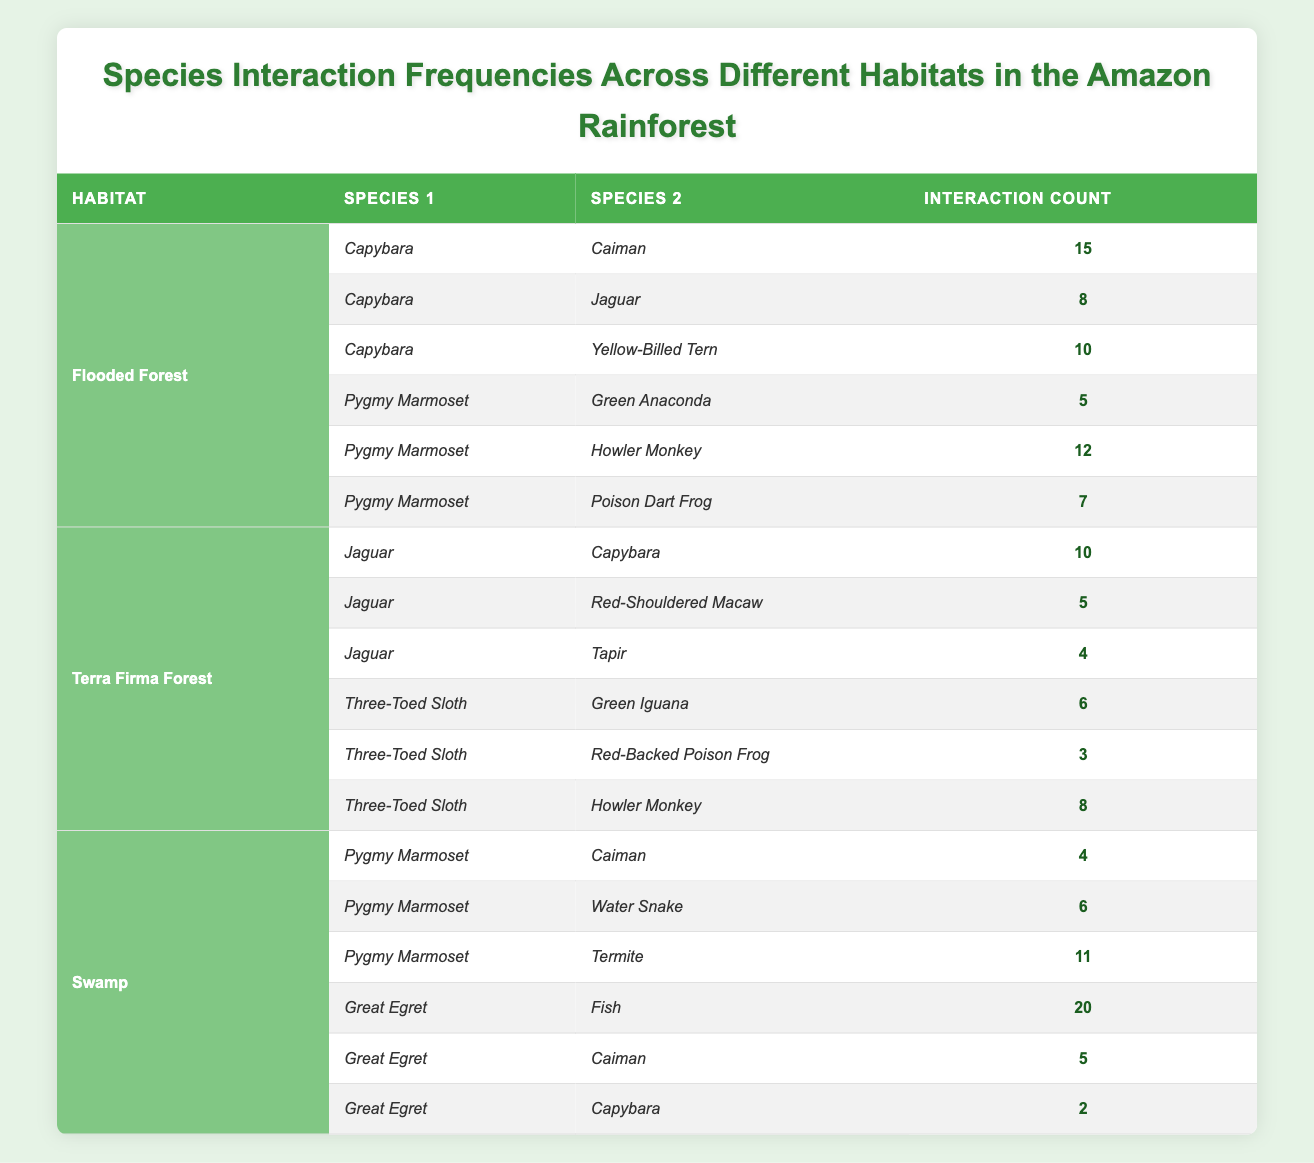What is the interaction count between Capybara and Caiman in the Flooded Forest? The table shows that in the Flooded Forest, the interaction count between Capybara and Caiman is 15.
Answer: 15 How many different species interactions are measured for the Pygmy Marmoset in the Flooded Forest? In the Flooded Forest, the Pygmy Marmoset interacts with three different species: Green Anaconda, Howler Monkey, and Poison Dart Frog.
Answer: 3 Which habitat has the highest recorded interaction for the Great Egret? The table indicates that in the Swamp habitat, the Great Egret has its highest recorded interaction count with Fish, totaling 20 interactions.
Answer: 20 What is the total interaction count for Jaguar across both habitats in the table? The Jaguar interacts with Capybara (10), Red-Shouldered Macaw (5), and Tapir (4) in the Terra Firma Forest, totaling 19 interactions. In the Flooded Forest, it interacts with Capybara (8), giving a total of 27 interactions overall (8 + 10 + 5 + 4 = 27).
Answer: 27 Is the interaction count between Pygmy Marmoset and Water Snake greater than that of Pygmy Marmoset and Green Anaconda? The interaction count between Pygmy Marmoset and Water Snake is 6, which is greater than the interaction count with Green Anaconda, which is 5. Hence, the statement is true.
Answer: Yes What is the difference in interaction counts between Capybara and Jaguar within the Flooded Forest? The interaction count for Capybara interacting with Jaguar is 8, while for Jaguar interacting with Capybara is also 10. To find the difference: 10 - 8 = 2.
Answer: 2 Which species has more interactions: Three-Toed Sloth or Pygmy Marmoset in the Terra Firma Forest? The Three-Toed Sloth interacts with Green Iguana (6), Red-Backed Poison Frog (3), and Howler Monkey (8), summing up to 17 interactions. The Pygmy Marmoset in the Flooded Forest has interactions with the Green Anaconda (5), Howler Monkey (12), and Poison Dart Frog (7), totaling 24 interactions. Therefore, Pygmy Marmoset has more interactions.
Answer: Pygmy Marmoset What is the sum of interaction counts for the Great Egret in the Swamp? The Great Egret has interaction counts of 20 with Fish, 5 with Caiman, and 2 with Capybara. Adding these together: 20 + 5 + 2 = 27.
Answer: 27 Are there any interactions recorded between Three-Toed Sloth and Caiman in the provided data? The data shows no interactions recorded between Three-Toed Sloth and Caiman, indicating that the statement is false.
Answer: No 